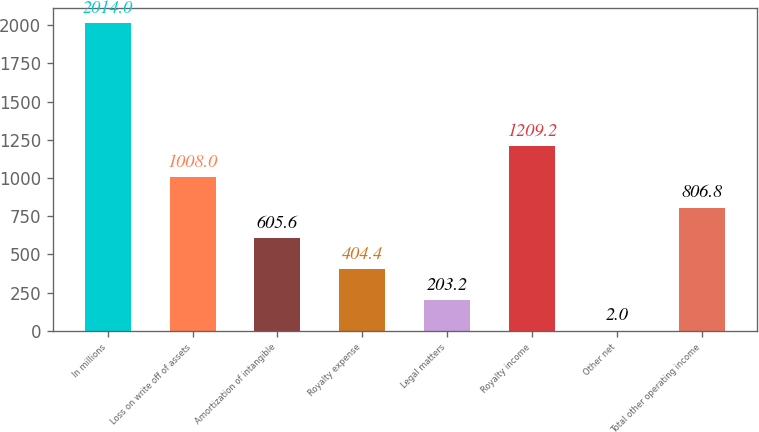<chart> <loc_0><loc_0><loc_500><loc_500><bar_chart><fcel>In millions<fcel>Loss on write off of assets<fcel>Amortization of intangible<fcel>Royalty expense<fcel>Legal matters<fcel>Royalty income<fcel>Other net<fcel>Total other operating income<nl><fcel>2014<fcel>1008<fcel>605.6<fcel>404.4<fcel>203.2<fcel>1209.2<fcel>2<fcel>806.8<nl></chart> 